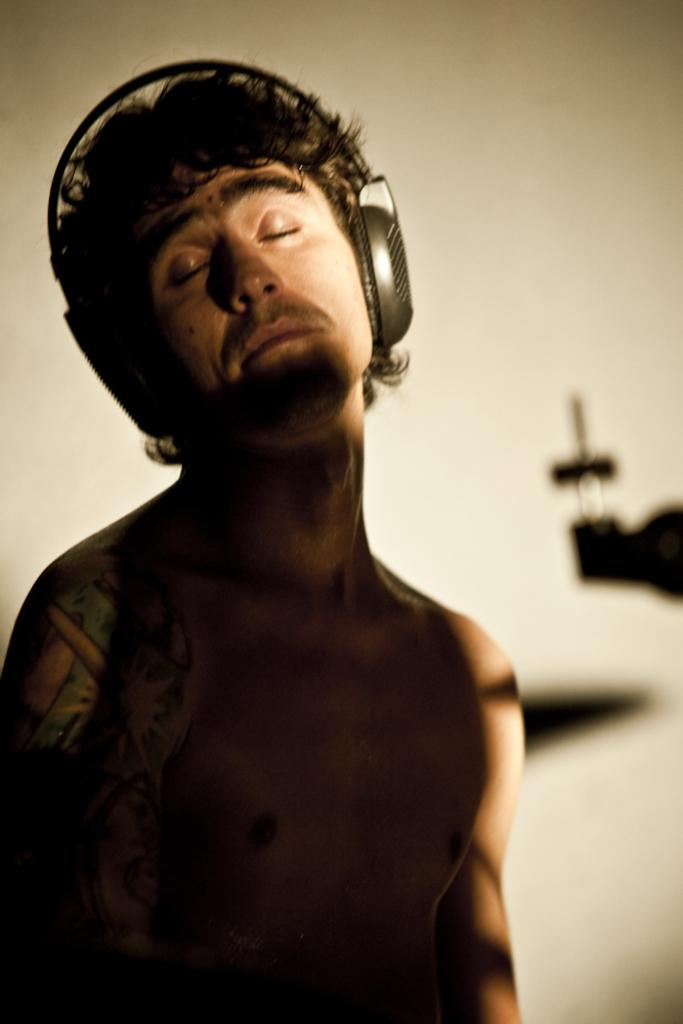What is the main subject in the foreground of the image? There is a person in the foreground of the image. What can be seen on the person's head? The person is wearing a headset. What is visible in the background of the image? There is a wall in the background of the image, and there are shadows of objects. What type of voyage is the person embarking on in the image? There is no indication of a voyage in the image; it only shows a person wearing a headset with a wall and shadows in the background. 